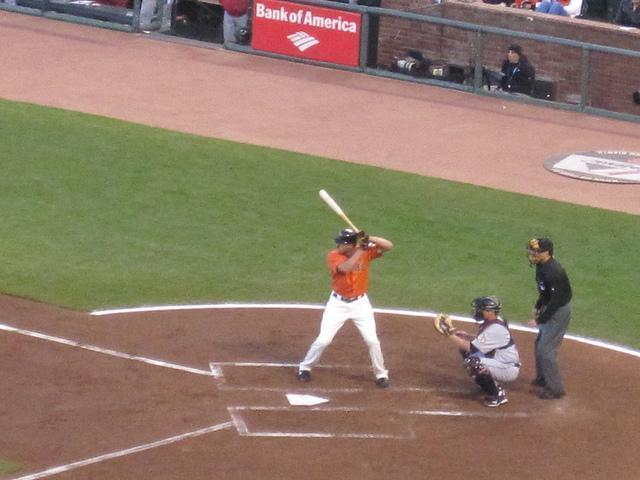What type of service sponsors this stadium?
Choose the right answer and clarify with the format: 'Answer: answer
Rationale: rationale.'
Options: Banking, dining, crafting, plumbing. Answer: banking.
Rationale: Banking services are the sponsor. 